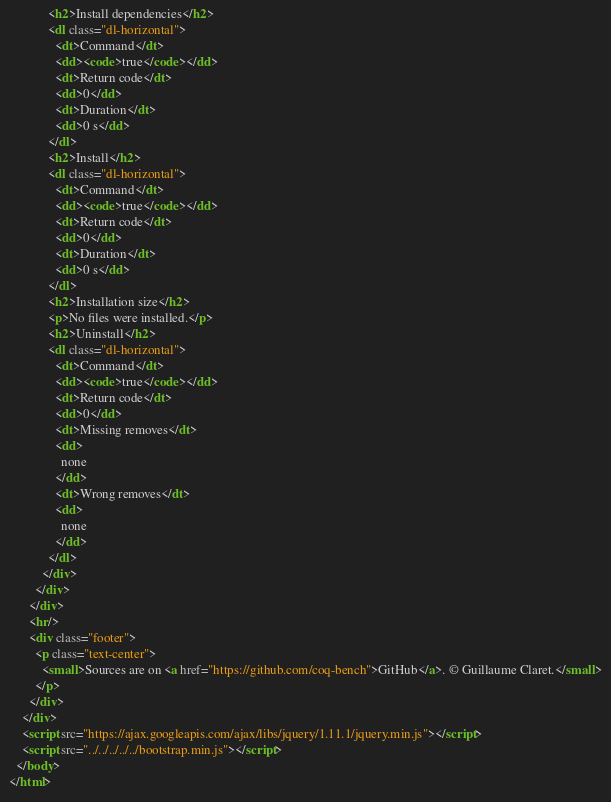Convert code to text. <code><loc_0><loc_0><loc_500><loc_500><_HTML_>            <h2>Install dependencies</h2>
            <dl class="dl-horizontal">
              <dt>Command</dt>
              <dd><code>true</code></dd>
              <dt>Return code</dt>
              <dd>0</dd>
              <dt>Duration</dt>
              <dd>0 s</dd>
            </dl>
            <h2>Install</h2>
            <dl class="dl-horizontal">
              <dt>Command</dt>
              <dd><code>true</code></dd>
              <dt>Return code</dt>
              <dd>0</dd>
              <dt>Duration</dt>
              <dd>0 s</dd>
            </dl>
            <h2>Installation size</h2>
            <p>No files were installed.</p>
            <h2>Uninstall</h2>
            <dl class="dl-horizontal">
              <dt>Command</dt>
              <dd><code>true</code></dd>
              <dt>Return code</dt>
              <dd>0</dd>
              <dt>Missing removes</dt>
              <dd>
                none
              </dd>
              <dt>Wrong removes</dt>
              <dd>
                none
              </dd>
            </dl>
          </div>
        </div>
      </div>
      <hr/>
      <div class="footer">
        <p class="text-center">
          <small>Sources are on <a href="https://github.com/coq-bench">GitHub</a>. © Guillaume Claret.</small>
        </p>
      </div>
    </div>
    <script src="https://ajax.googleapis.com/ajax/libs/jquery/1.11.1/jquery.min.js"></script>
    <script src="../../../../../bootstrap.min.js"></script>
  </body>
</html>
</code> 